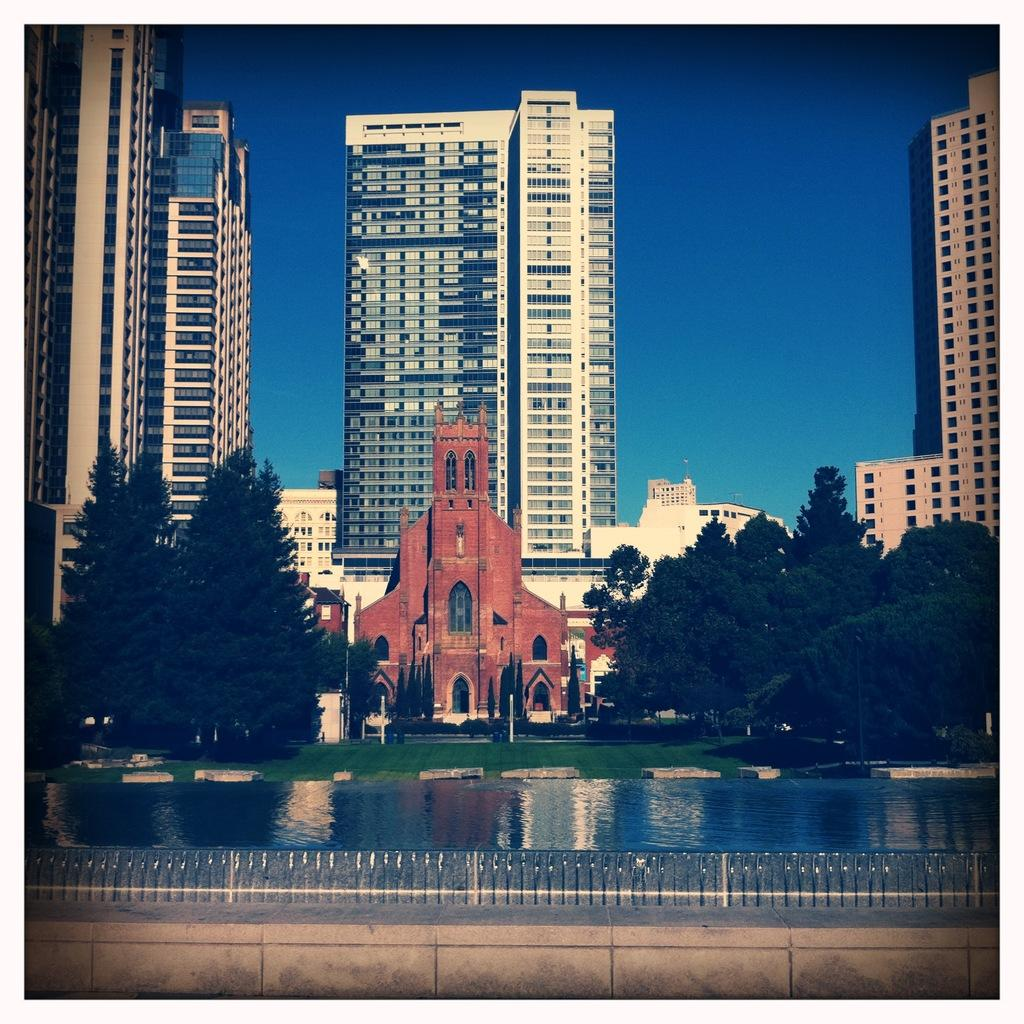What can be seen in the background of the image? In the background of the image, there is a sky, skyscrapers, a building, and trees on both the right and left sides. What natural elements are visible in the image? Water and grass are visible in the image. Is there any man-made structure in the image? Yes, there is a fence in the image. Where is the lunchroom located in the image? There is no lunchroom present in the image. What type of trail can be seen in the image? There is no trail visible in the image. 